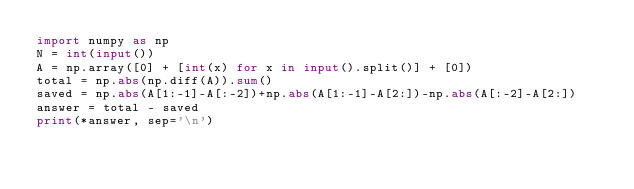<code> <loc_0><loc_0><loc_500><loc_500><_Python_>import numpy as np
N = int(input())
A = np.array([0] + [int(x) for x in input().split()] + [0])
total = np.abs(np.diff(A)).sum()
saved = np.abs(A[1:-1]-A[:-2])+np.abs(A[1:-1]-A[2:])-np.abs(A[:-2]-A[2:])
answer = total - saved
print(*answer, sep='\n')
</code> 